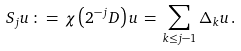Convert formula to latex. <formula><loc_0><loc_0><loc_500><loc_500>S _ { j } u \, \colon = \, \chi \left ( 2 ^ { - j } D \right ) u \, = \, \sum _ { k \leq j - 1 } \Delta _ { k } u \, .</formula> 